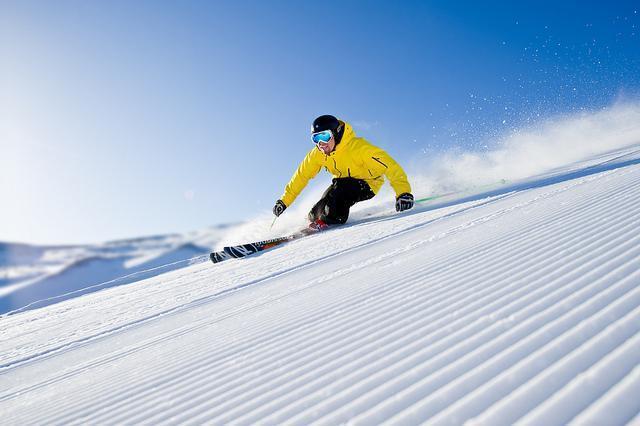How many black railroad cars are at the train station?
Give a very brief answer. 0. 